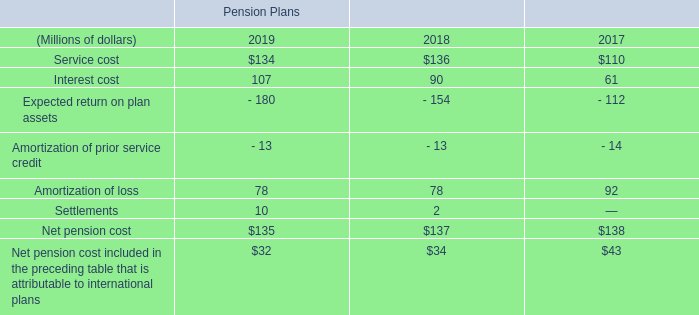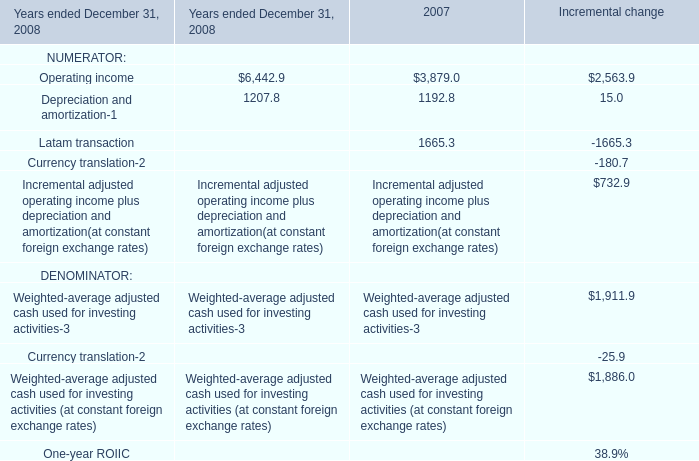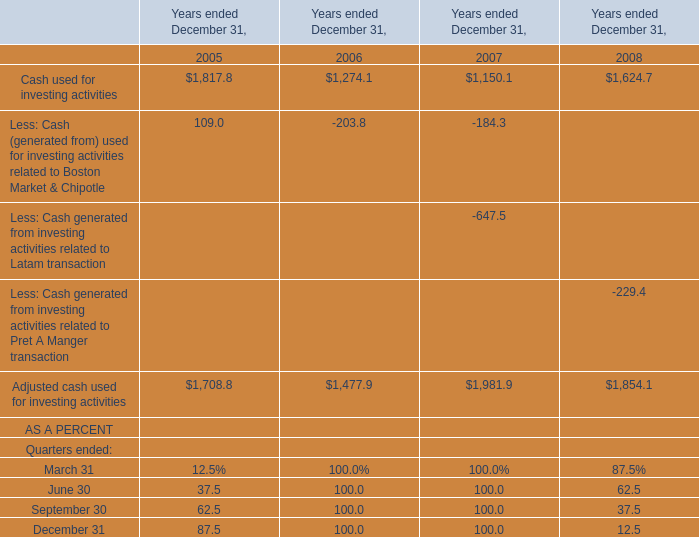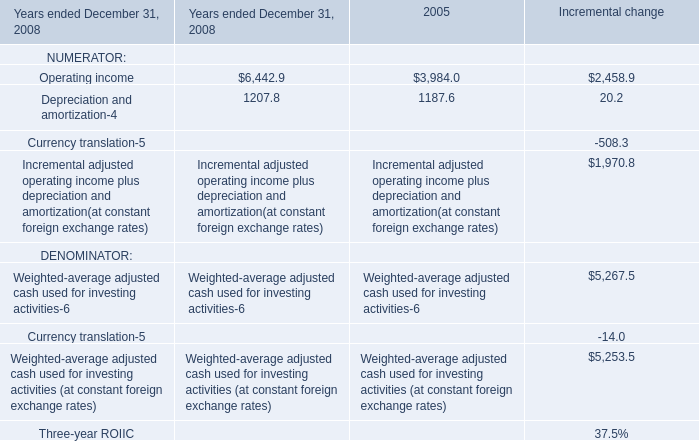What's the average of Latam transaction of 2007, and Depreciation and amortization of 2005 ? 
Computations: ((1665.3 + 1207.8) / 2)
Answer: 1436.55. 